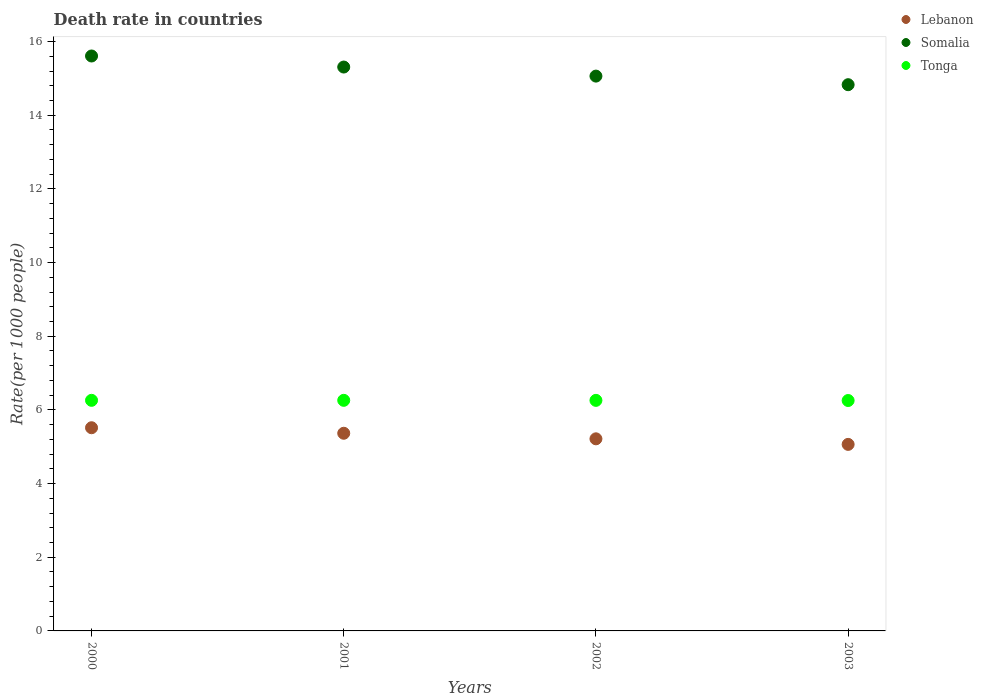Is the number of dotlines equal to the number of legend labels?
Provide a short and direct response. Yes. What is the death rate in Tonga in 2001?
Give a very brief answer. 6.26. Across all years, what is the maximum death rate in Lebanon?
Your response must be concise. 5.52. Across all years, what is the minimum death rate in Lebanon?
Your answer should be very brief. 5.06. In which year was the death rate in Lebanon maximum?
Provide a short and direct response. 2000. In which year was the death rate in Lebanon minimum?
Offer a terse response. 2003. What is the total death rate in Lebanon in the graph?
Give a very brief answer. 21.16. What is the difference between the death rate in Somalia in 2000 and that in 2003?
Provide a short and direct response. 0.78. What is the difference between the death rate in Lebanon in 2002 and the death rate in Tonga in 2000?
Give a very brief answer. -1.04. What is the average death rate in Somalia per year?
Offer a very short reply. 15.2. In the year 2002, what is the difference between the death rate in Somalia and death rate in Lebanon?
Offer a terse response. 9.85. What is the ratio of the death rate in Somalia in 2002 to that in 2003?
Make the answer very short. 1.02. Is the difference between the death rate in Somalia in 2001 and 2003 greater than the difference between the death rate in Lebanon in 2001 and 2003?
Make the answer very short. Yes. What is the difference between the highest and the second highest death rate in Somalia?
Offer a terse response. 0.3. What is the difference between the highest and the lowest death rate in Tonga?
Offer a terse response. 0. Is the sum of the death rate in Somalia in 2002 and 2003 greater than the maximum death rate in Tonga across all years?
Ensure brevity in your answer.  Yes. Is it the case that in every year, the sum of the death rate in Tonga and death rate in Lebanon  is greater than the death rate in Somalia?
Your answer should be compact. No. Does the death rate in Lebanon monotonically increase over the years?
Your answer should be very brief. No. Is the death rate in Tonga strictly less than the death rate in Somalia over the years?
Your answer should be compact. Yes. How many dotlines are there?
Give a very brief answer. 3. How many years are there in the graph?
Provide a short and direct response. 4. What is the difference between two consecutive major ticks on the Y-axis?
Your answer should be compact. 2. Are the values on the major ticks of Y-axis written in scientific E-notation?
Give a very brief answer. No. Does the graph contain any zero values?
Keep it short and to the point. No. What is the title of the graph?
Keep it short and to the point. Death rate in countries. Does "Thailand" appear as one of the legend labels in the graph?
Give a very brief answer. No. What is the label or title of the X-axis?
Ensure brevity in your answer.  Years. What is the label or title of the Y-axis?
Provide a short and direct response. Rate(per 1000 people). What is the Rate(per 1000 people) in Lebanon in 2000?
Offer a terse response. 5.52. What is the Rate(per 1000 people) in Somalia in 2000?
Your response must be concise. 15.61. What is the Rate(per 1000 people) in Tonga in 2000?
Provide a succinct answer. 6.26. What is the Rate(per 1000 people) of Lebanon in 2001?
Your answer should be compact. 5.37. What is the Rate(per 1000 people) in Somalia in 2001?
Ensure brevity in your answer.  15.31. What is the Rate(per 1000 people) in Tonga in 2001?
Give a very brief answer. 6.26. What is the Rate(per 1000 people) in Lebanon in 2002?
Provide a succinct answer. 5.21. What is the Rate(per 1000 people) in Somalia in 2002?
Give a very brief answer. 15.06. What is the Rate(per 1000 people) in Tonga in 2002?
Your answer should be compact. 6.26. What is the Rate(per 1000 people) in Lebanon in 2003?
Make the answer very short. 5.06. What is the Rate(per 1000 people) in Somalia in 2003?
Offer a terse response. 14.83. What is the Rate(per 1000 people) in Tonga in 2003?
Offer a terse response. 6.25. Across all years, what is the maximum Rate(per 1000 people) of Lebanon?
Keep it short and to the point. 5.52. Across all years, what is the maximum Rate(per 1000 people) in Somalia?
Make the answer very short. 15.61. Across all years, what is the maximum Rate(per 1000 people) of Tonga?
Your response must be concise. 6.26. Across all years, what is the minimum Rate(per 1000 people) of Lebanon?
Offer a very short reply. 5.06. Across all years, what is the minimum Rate(per 1000 people) in Somalia?
Provide a succinct answer. 14.83. Across all years, what is the minimum Rate(per 1000 people) in Tonga?
Provide a succinct answer. 6.25. What is the total Rate(per 1000 people) in Lebanon in the graph?
Your answer should be compact. 21.16. What is the total Rate(per 1000 people) in Somalia in the graph?
Offer a very short reply. 60.81. What is the total Rate(per 1000 people) of Tonga in the graph?
Provide a succinct answer. 25.03. What is the difference between the Rate(per 1000 people) of Lebanon in 2000 and that in 2001?
Provide a succinct answer. 0.15. What is the difference between the Rate(per 1000 people) of Lebanon in 2000 and that in 2002?
Give a very brief answer. 0.3. What is the difference between the Rate(per 1000 people) in Somalia in 2000 and that in 2002?
Offer a terse response. 0.55. What is the difference between the Rate(per 1000 people) of Tonga in 2000 and that in 2002?
Offer a terse response. 0. What is the difference between the Rate(per 1000 people) of Lebanon in 2000 and that in 2003?
Offer a very short reply. 0.45. What is the difference between the Rate(per 1000 people) of Somalia in 2000 and that in 2003?
Make the answer very short. 0.78. What is the difference between the Rate(per 1000 people) of Tonga in 2000 and that in 2003?
Make the answer very short. 0.01. What is the difference between the Rate(per 1000 people) of Lebanon in 2001 and that in 2002?
Provide a short and direct response. 0.15. What is the difference between the Rate(per 1000 people) in Somalia in 2001 and that in 2002?
Make the answer very short. 0.25. What is the difference between the Rate(per 1000 people) in Lebanon in 2001 and that in 2003?
Your answer should be very brief. 0.3. What is the difference between the Rate(per 1000 people) of Somalia in 2001 and that in 2003?
Provide a short and direct response. 0.48. What is the difference between the Rate(per 1000 people) of Tonga in 2001 and that in 2003?
Offer a very short reply. 0.01. What is the difference between the Rate(per 1000 people) of Lebanon in 2002 and that in 2003?
Your response must be concise. 0.15. What is the difference between the Rate(per 1000 people) in Somalia in 2002 and that in 2003?
Give a very brief answer. 0.23. What is the difference between the Rate(per 1000 people) of Tonga in 2002 and that in 2003?
Ensure brevity in your answer.  0. What is the difference between the Rate(per 1000 people) in Lebanon in 2000 and the Rate(per 1000 people) in Somalia in 2001?
Provide a short and direct response. -9.79. What is the difference between the Rate(per 1000 people) of Lebanon in 2000 and the Rate(per 1000 people) of Tonga in 2001?
Offer a terse response. -0.74. What is the difference between the Rate(per 1000 people) in Somalia in 2000 and the Rate(per 1000 people) in Tonga in 2001?
Keep it short and to the point. 9.35. What is the difference between the Rate(per 1000 people) of Lebanon in 2000 and the Rate(per 1000 people) of Somalia in 2002?
Your answer should be compact. -9.55. What is the difference between the Rate(per 1000 people) of Lebanon in 2000 and the Rate(per 1000 people) of Tonga in 2002?
Keep it short and to the point. -0.74. What is the difference between the Rate(per 1000 people) in Somalia in 2000 and the Rate(per 1000 people) in Tonga in 2002?
Provide a succinct answer. 9.35. What is the difference between the Rate(per 1000 people) in Lebanon in 2000 and the Rate(per 1000 people) in Somalia in 2003?
Offer a very short reply. -9.31. What is the difference between the Rate(per 1000 people) in Lebanon in 2000 and the Rate(per 1000 people) in Tonga in 2003?
Your answer should be very brief. -0.74. What is the difference between the Rate(per 1000 people) of Somalia in 2000 and the Rate(per 1000 people) of Tonga in 2003?
Provide a succinct answer. 9.35. What is the difference between the Rate(per 1000 people) in Lebanon in 2001 and the Rate(per 1000 people) in Somalia in 2002?
Keep it short and to the point. -9.7. What is the difference between the Rate(per 1000 people) of Lebanon in 2001 and the Rate(per 1000 people) of Tonga in 2002?
Offer a terse response. -0.89. What is the difference between the Rate(per 1000 people) in Somalia in 2001 and the Rate(per 1000 people) in Tonga in 2002?
Give a very brief answer. 9.05. What is the difference between the Rate(per 1000 people) in Lebanon in 2001 and the Rate(per 1000 people) in Somalia in 2003?
Provide a short and direct response. -9.46. What is the difference between the Rate(per 1000 people) of Lebanon in 2001 and the Rate(per 1000 people) of Tonga in 2003?
Offer a terse response. -0.89. What is the difference between the Rate(per 1000 people) of Somalia in 2001 and the Rate(per 1000 people) of Tonga in 2003?
Offer a very short reply. 9.05. What is the difference between the Rate(per 1000 people) of Lebanon in 2002 and the Rate(per 1000 people) of Somalia in 2003?
Provide a succinct answer. -9.61. What is the difference between the Rate(per 1000 people) in Lebanon in 2002 and the Rate(per 1000 people) in Tonga in 2003?
Make the answer very short. -1.04. What is the difference between the Rate(per 1000 people) of Somalia in 2002 and the Rate(per 1000 people) of Tonga in 2003?
Make the answer very short. 8.81. What is the average Rate(per 1000 people) of Lebanon per year?
Offer a very short reply. 5.29. What is the average Rate(per 1000 people) in Somalia per year?
Provide a succinct answer. 15.2. What is the average Rate(per 1000 people) in Tonga per year?
Provide a short and direct response. 6.26. In the year 2000, what is the difference between the Rate(per 1000 people) of Lebanon and Rate(per 1000 people) of Somalia?
Offer a terse response. -10.09. In the year 2000, what is the difference between the Rate(per 1000 people) of Lebanon and Rate(per 1000 people) of Tonga?
Your answer should be very brief. -0.74. In the year 2000, what is the difference between the Rate(per 1000 people) of Somalia and Rate(per 1000 people) of Tonga?
Give a very brief answer. 9.35. In the year 2001, what is the difference between the Rate(per 1000 people) of Lebanon and Rate(per 1000 people) of Somalia?
Keep it short and to the point. -9.94. In the year 2001, what is the difference between the Rate(per 1000 people) of Lebanon and Rate(per 1000 people) of Tonga?
Provide a succinct answer. -0.89. In the year 2001, what is the difference between the Rate(per 1000 people) of Somalia and Rate(per 1000 people) of Tonga?
Keep it short and to the point. 9.05. In the year 2002, what is the difference between the Rate(per 1000 people) of Lebanon and Rate(per 1000 people) of Somalia?
Provide a short and direct response. -9.85. In the year 2002, what is the difference between the Rate(per 1000 people) of Lebanon and Rate(per 1000 people) of Tonga?
Offer a very short reply. -1.04. In the year 2002, what is the difference between the Rate(per 1000 people) in Somalia and Rate(per 1000 people) in Tonga?
Provide a short and direct response. 8.8. In the year 2003, what is the difference between the Rate(per 1000 people) of Lebanon and Rate(per 1000 people) of Somalia?
Provide a short and direct response. -9.77. In the year 2003, what is the difference between the Rate(per 1000 people) in Lebanon and Rate(per 1000 people) in Tonga?
Provide a short and direct response. -1.19. In the year 2003, what is the difference between the Rate(per 1000 people) of Somalia and Rate(per 1000 people) of Tonga?
Your answer should be very brief. 8.57. What is the ratio of the Rate(per 1000 people) of Lebanon in 2000 to that in 2001?
Keep it short and to the point. 1.03. What is the ratio of the Rate(per 1000 people) in Somalia in 2000 to that in 2001?
Offer a very short reply. 1.02. What is the ratio of the Rate(per 1000 people) in Lebanon in 2000 to that in 2002?
Your answer should be compact. 1.06. What is the ratio of the Rate(per 1000 people) of Somalia in 2000 to that in 2002?
Provide a short and direct response. 1.04. What is the ratio of the Rate(per 1000 people) in Lebanon in 2000 to that in 2003?
Give a very brief answer. 1.09. What is the ratio of the Rate(per 1000 people) of Somalia in 2000 to that in 2003?
Keep it short and to the point. 1.05. What is the ratio of the Rate(per 1000 people) in Tonga in 2000 to that in 2003?
Offer a very short reply. 1. What is the ratio of the Rate(per 1000 people) of Lebanon in 2001 to that in 2002?
Give a very brief answer. 1.03. What is the ratio of the Rate(per 1000 people) in Somalia in 2001 to that in 2002?
Offer a very short reply. 1.02. What is the ratio of the Rate(per 1000 people) of Tonga in 2001 to that in 2002?
Ensure brevity in your answer.  1. What is the ratio of the Rate(per 1000 people) in Lebanon in 2001 to that in 2003?
Keep it short and to the point. 1.06. What is the ratio of the Rate(per 1000 people) in Somalia in 2001 to that in 2003?
Make the answer very short. 1.03. What is the ratio of the Rate(per 1000 people) of Lebanon in 2002 to that in 2003?
Offer a terse response. 1.03. What is the ratio of the Rate(per 1000 people) in Somalia in 2002 to that in 2003?
Provide a succinct answer. 1.02. What is the difference between the highest and the second highest Rate(per 1000 people) in Tonga?
Provide a short and direct response. 0. What is the difference between the highest and the lowest Rate(per 1000 people) of Lebanon?
Provide a short and direct response. 0.45. What is the difference between the highest and the lowest Rate(per 1000 people) in Somalia?
Make the answer very short. 0.78. What is the difference between the highest and the lowest Rate(per 1000 people) in Tonga?
Your answer should be very brief. 0.01. 